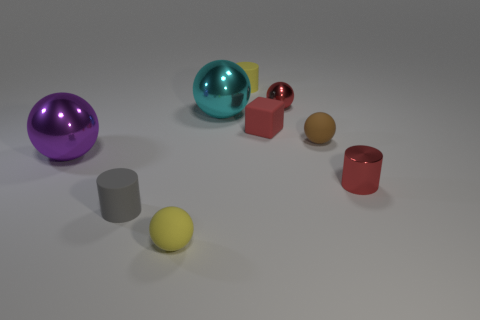Are there any objects that stand out due to their positioning? Yes, the yellow sphere stands out because it's placed separately from the other objects, which are grouped closer together. 